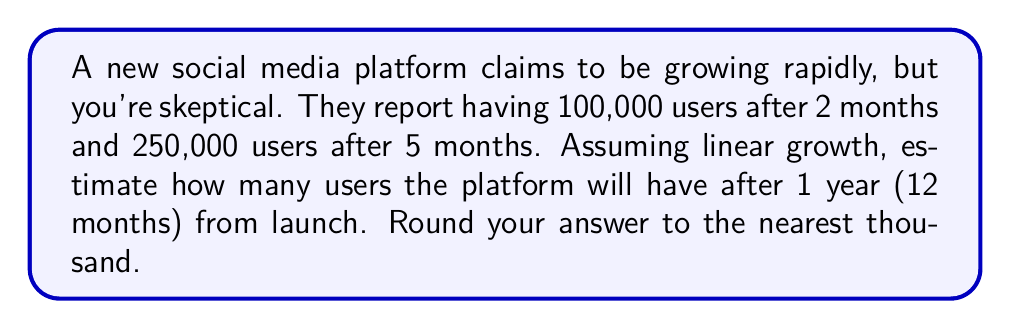Give your solution to this math problem. Let's approach this step-by-step:

1) We can use the linear equation $y = mx + b$, where:
   $y$ is the number of users
   $x$ is the number of months
   $m$ is the slope (rate of growth)
   $b$ is the y-intercept (initial number of users)

2) We have two points: (2, 100,000) and (5, 250,000)

3) Calculate the slope:
   $m = \frac{y_2 - y_1}{x_2 - x_1} = \frac{250,000 - 100,000}{5 - 2} = \frac{150,000}{3} = 50,000$ users/month

4) Use either point to find $b$:
   $100,000 = 50,000(2) + b$
   $b = 100,000 - 100,000 = 0$

5) Our equation is: $y = 50,000x + 0$ or simply $y = 50,000x$

6) To find users after 12 months, plug in $x = 12$:
   $y = 50,000(12) = 600,000$

7) Rounding to the nearest thousand: 600,000
Answer: 600,000 users 